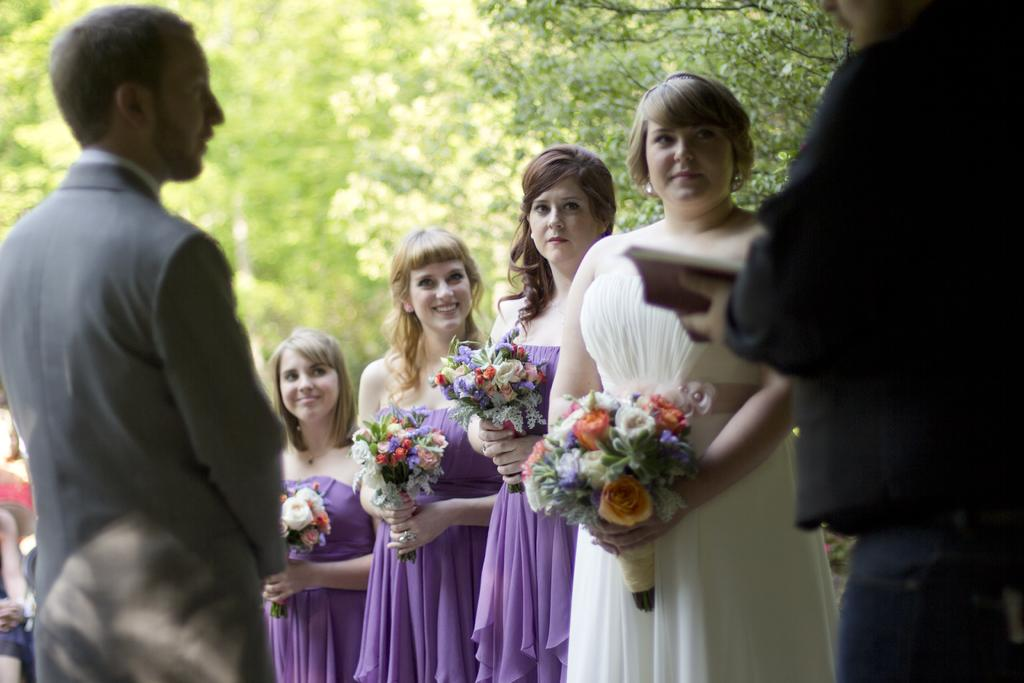How many people are present in the image? There are two men in the image. What is one of the men holding? One of the men is holding a book. What are the women holding in the image? The women are holding flower bouquets in the image. What can be seen in the background of the image? There are trees in the background of the image. What type of story is the man telling the country in the image? There is no indication in the image that a story is being told or that a country is involved. 